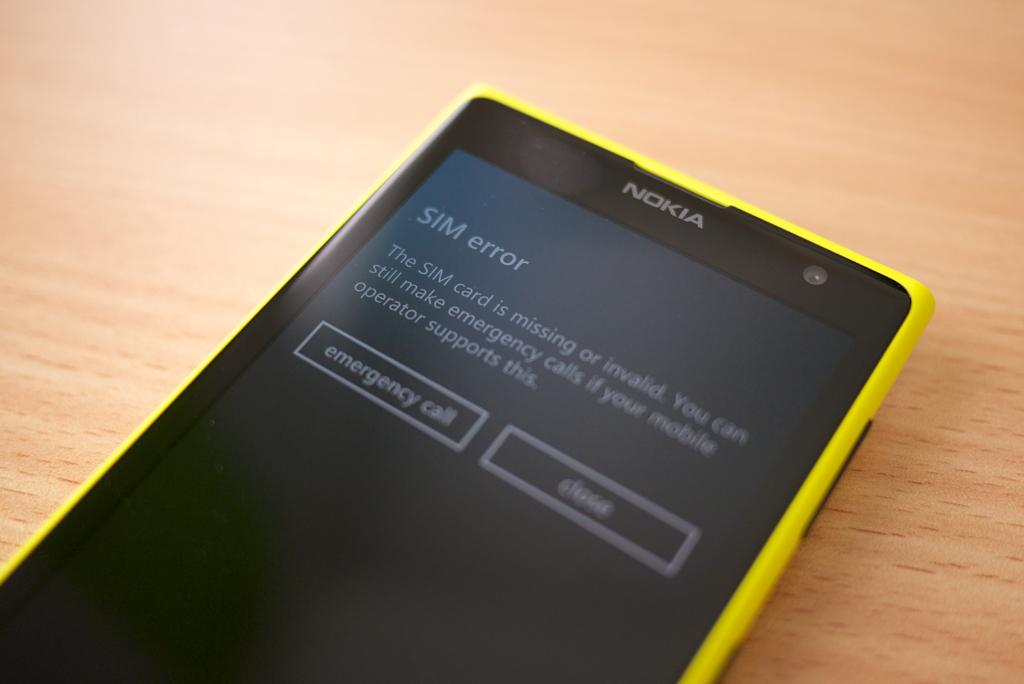Provide a one-sentence caption for the provided image. A yellow Nokia cell phone that shows a SIM error on the screen. 